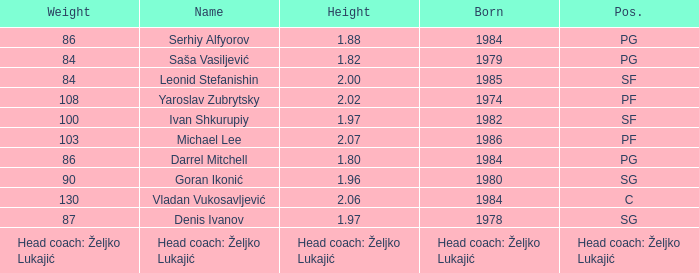Which position did Michael Lee play? PF. 